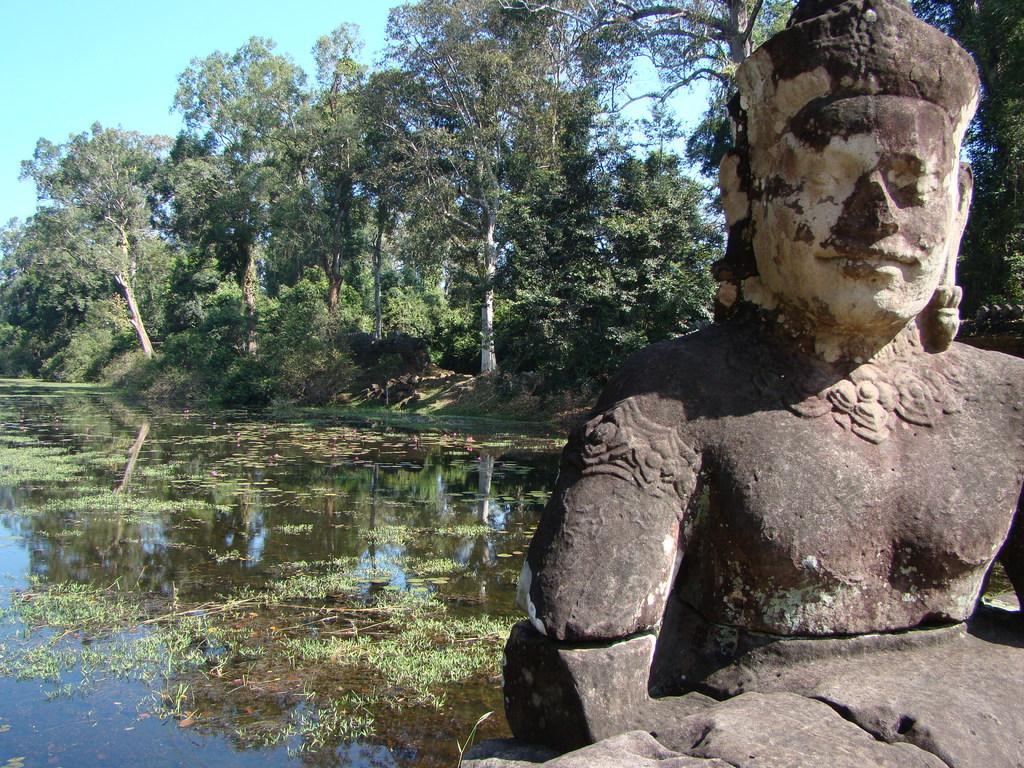How would you summarize this image in a sentence or two? This image is taken outdoors. At the top of the image there is the sky. In the background there are many trees and plants with leaves, stems and branches. On the left side of the image there is a pond with water. There is an algae in the pond. On the right side of the image there is a sculpture. 